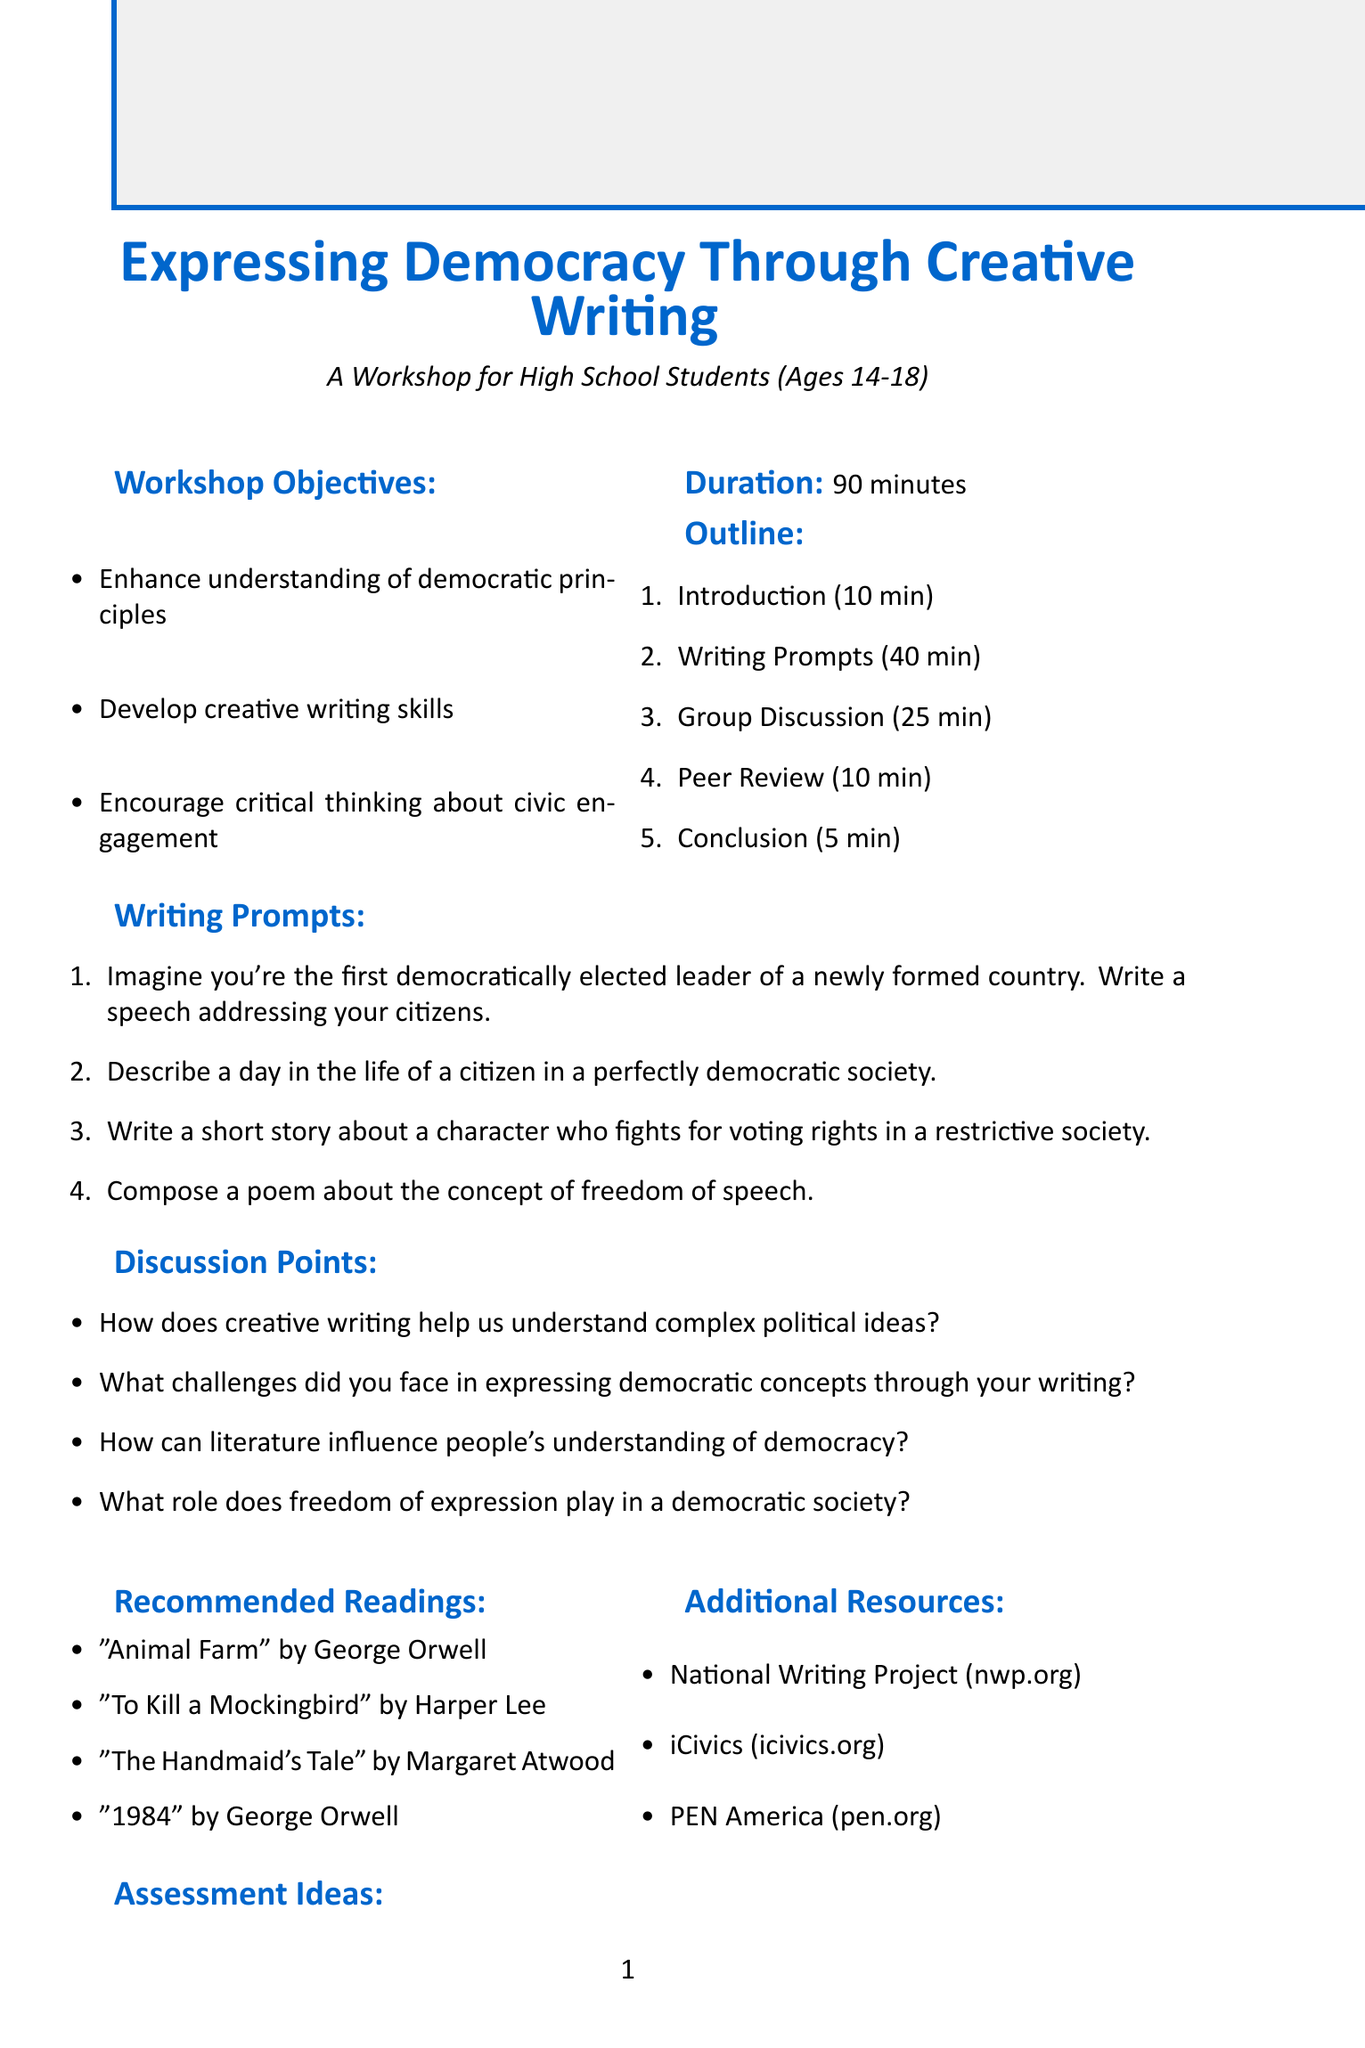What is the title of the workshop? The title of the workshop is clearly stated at the top of the document.
Answer: Expressing Democracy Through Creative Writing Who is the target audience for the workshop? The target audience is specified in the opening section of the document.
Answer: High school students aged 14-18 How long is the workshop scheduled to last? The duration of the workshop is mentioned in the introductory section.
Answer: 90 minutes What is one of the objectives of the workshop? There are multiple objectives listed in the workshop objectives section.
Answer: Enhance understanding of democratic principles How many writing prompts are provided? The number of writing prompts can be found in the corresponding section of the outline.
Answer: 4 What is one of the discussions points? Discussion points are outlined to provoke thought and conversation during the workshop.
Answer: How can literature influence people's understanding of democracy? What type of assessment idea involves creating a class book? The assessment ideas include various methods to evaluate student work.
Answer: Create a class anthology of democracy-themed writings Name one of the recommended readings. The document lists suggested literature that relates to the themes discussed in the workshop.
Answer: Animal Farm by George Orwell What additional resource focuses on civic education? Additional resources in the document offer further reading or educational opportunities related to the workshop's theme.
Answer: iCivics 